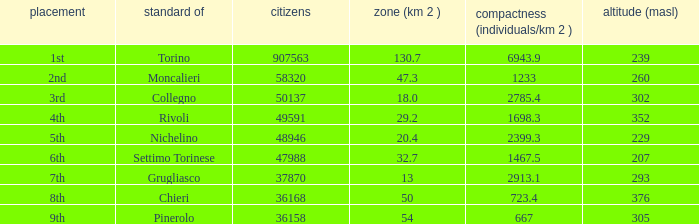What is the density of the common with an area of 20.4 km^2? 2399.3. 